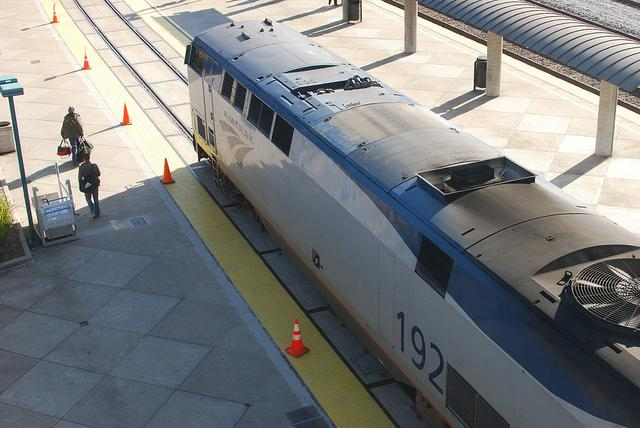What is the sum of the three digits on the train? twelve 